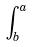Convert formula to latex. <formula><loc_0><loc_0><loc_500><loc_500>\int _ { b } ^ { a }</formula> 